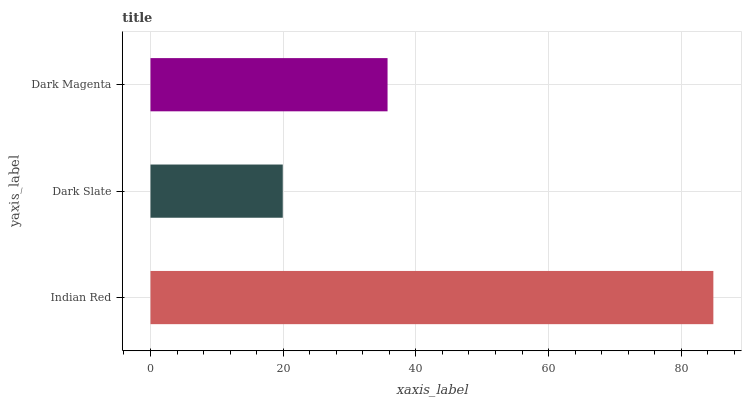Is Dark Slate the minimum?
Answer yes or no. Yes. Is Indian Red the maximum?
Answer yes or no. Yes. Is Dark Magenta the minimum?
Answer yes or no. No. Is Dark Magenta the maximum?
Answer yes or no. No. Is Dark Magenta greater than Dark Slate?
Answer yes or no. Yes. Is Dark Slate less than Dark Magenta?
Answer yes or no. Yes. Is Dark Slate greater than Dark Magenta?
Answer yes or no. No. Is Dark Magenta less than Dark Slate?
Answer yes or no. No. Is Dark Magenta the high median?
Answer yes or no. Yes. Is Dark Magenta the low median?
Answer yes or no. Yes. Is Dark Slate the high median?
Answer yes or no. No. Is Indian Red the low median?
Answer yes or no. No. 